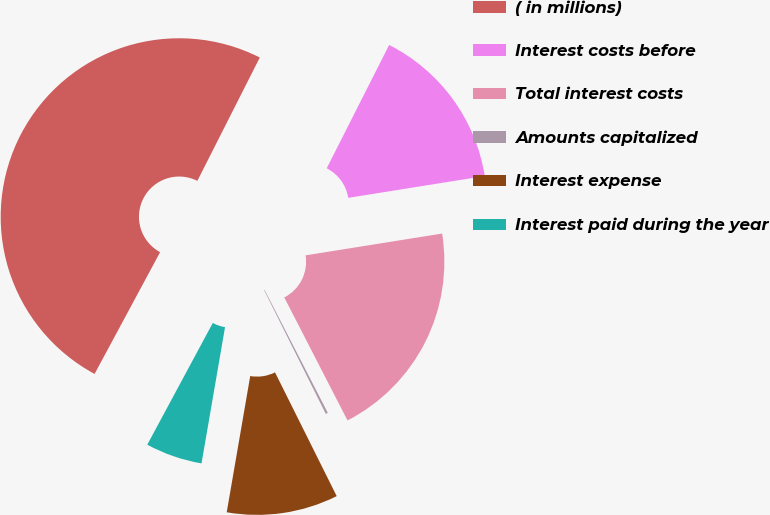<chart> <loc_0><loc_0><loc_500><loc_500><pie_chart><fcel>( in millions)<fcel>Interest costs before<fcel>Total interest costs<fcel>Amounts capitalized<fcel>Interest expense<fcel>Interest paid during the year<nl><fcel>49.6%<fcel>15.02%<fcel>19.96%<fcel>0.2%<fcel>10.08%<fcel>5.14%<nl></chart> 